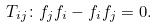<formula> <loc_0><loc_0><loc_500><loc_500>T _ { i j } \colon f _ { j } f _ { i } - f _ { i } f _ { j } = 0 .</formula> 